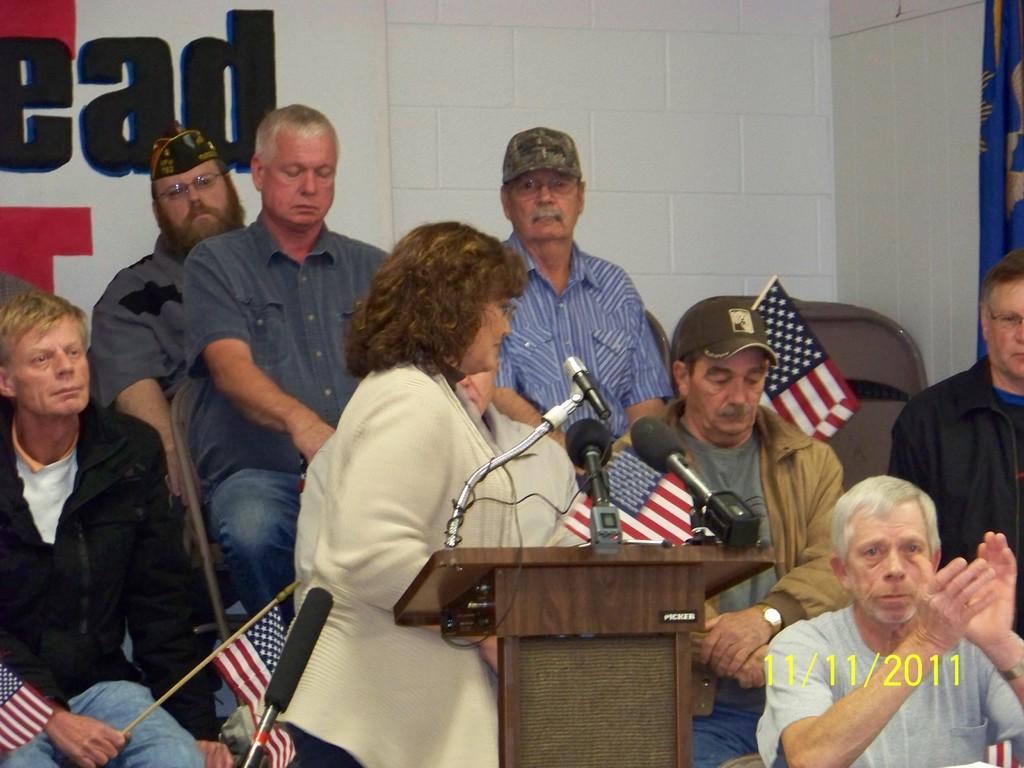How would you summarize this image in a sentence or two? This woman is standing in-front of this podium. On this podium there are mics. This is an american flag. Few persons are sitting on chair and holding american flag. A banner on wall. 